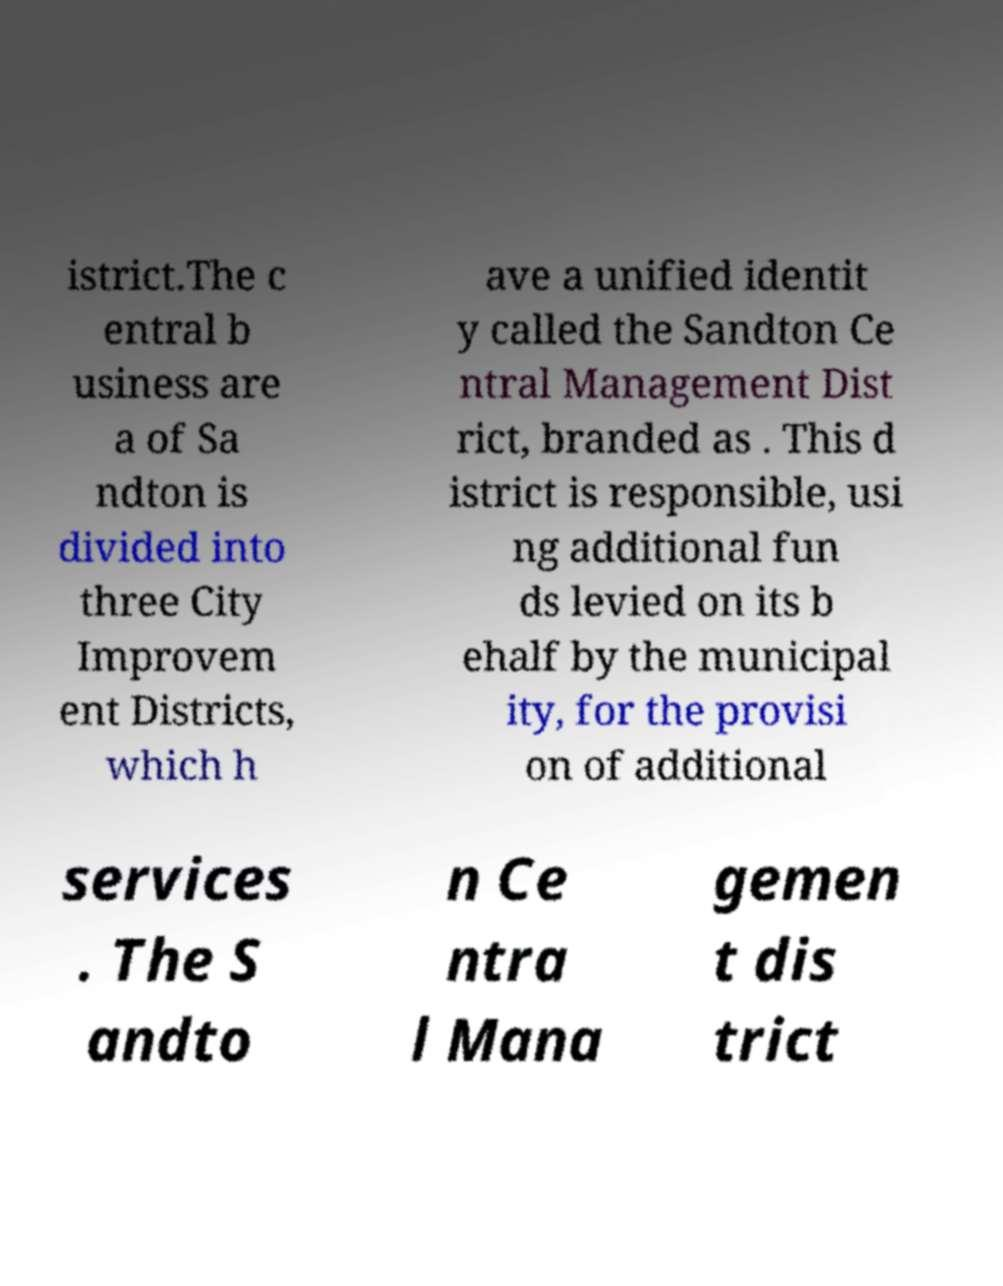For documentation purposes, I need the text within this image transcribed. Could you provide that? istrict.The c entral b usiness are a of Sa ndton is divided into three City Improvem ent Districts, which h ave a unified identit y called the Sandton Ce ntral Management Dist rict, branded as . This d istrict is responsible, usi ng additional fun ds levied on its b ehalf by the municipal ity, for the provisi on of additional services . The S andto n Ce ntra l Mana gemen t dis trict 